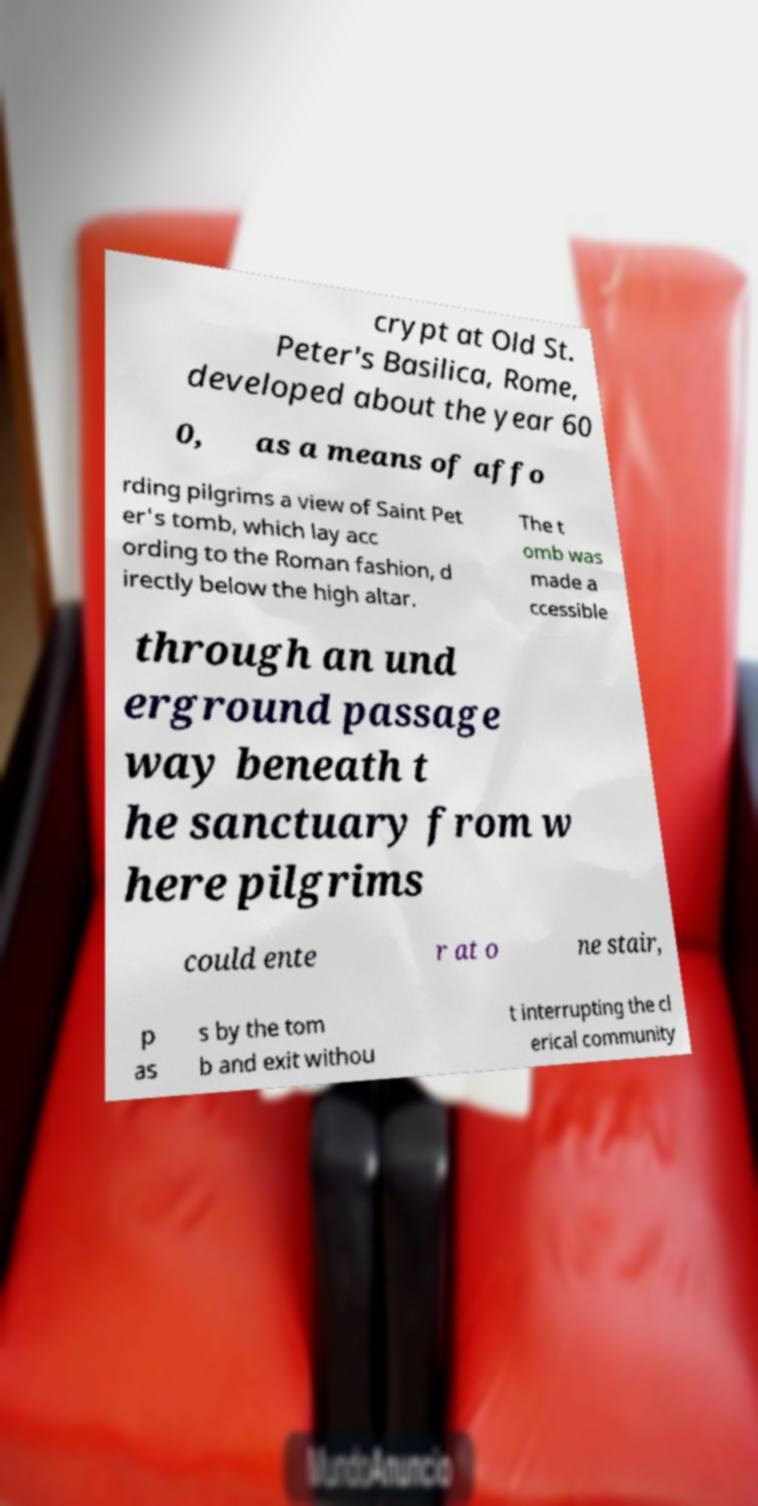Could you extract and type out the text from this image? crypt at Old St. Peter's Basilica, Rome, developed about the year 60 0, as a means of affo rding pilgrims a view of Saint Pet er's tomb, which lay acc ording to the Roman fashion, d irectly below the high altar. The t omb was made a ccessible through an und erground passage way beneath t he sanctuary from w here pilgrims could ente r at o ne stair, p as s by the tom b and exit withou t interrupting the cl erical community 